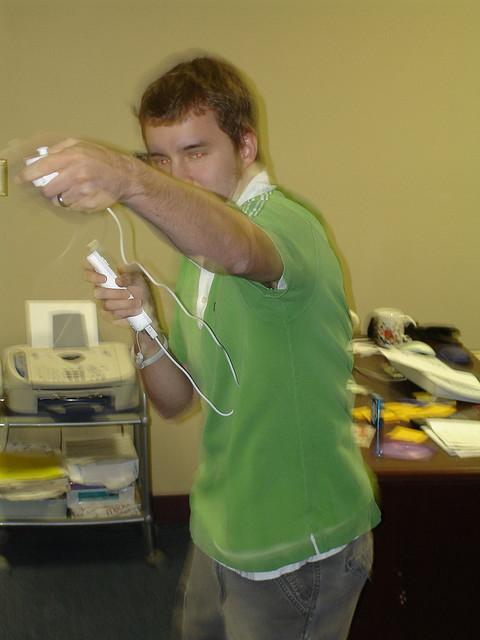What office equipment is on the shelf?

Choices:
A) stapler
B) fax
C) copier
D) computer fax 